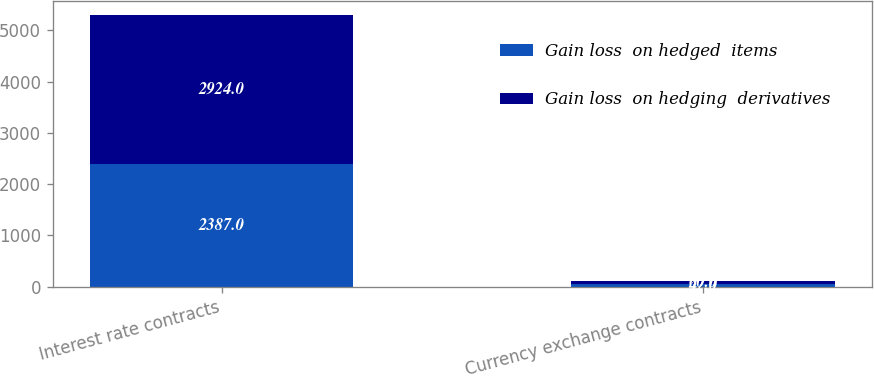Convert chart. <chart><loc_0><loc_0><loc_500><loc_500><stacked_bar_chart><ecel><fcel>Interest rate contracts<fcel>Currency exchange contracts<nl><fcel>Gain loss  on hedged  items<fcel>2387<fcel>47<nl><fcel>Gain loss  on hedging  derivatives<fcel>2924<fcel>60<nl></chart> 